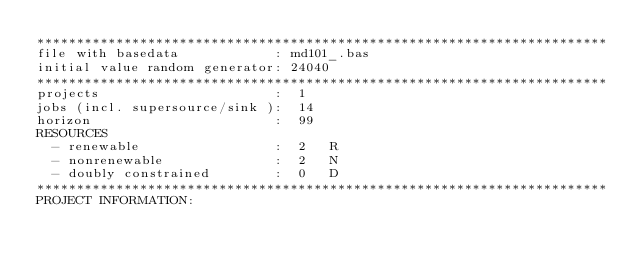Convert code to text. <code><loc_0><loc_0><loc_500><loc_500><_ObjectiveC_>************************************************************************
file with basedata            : md101_.bas
initial value random generator: 24040
************************************************************************
projects                      :  1
jobs (incl. supersource/sink ):  14
horizon                       :  99
RESOURCES
  - renewable                 :  2   R
  - nonrenewable              :  2   N
  - doubly constrained        :  0   D
************************************************************************
PROJECT INFORMATION:</code> 